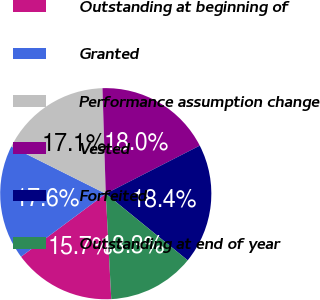Convert chart to OTSL. <chart><loc_0><loc_0><loc_500><loc_500><pie_chart><fcel>Outstanding at beginning of<fcel>Granted<fcel>Performance assumption change<fcel>Vested<fcel>Forfeited<fcel>Outstanding at end of year<nl><fcel>15.65%<fcel>17.55%<fcel>17.13%<fcel>17.97%<fcel>18.39%<fcel>13.3%<nl></chart> 